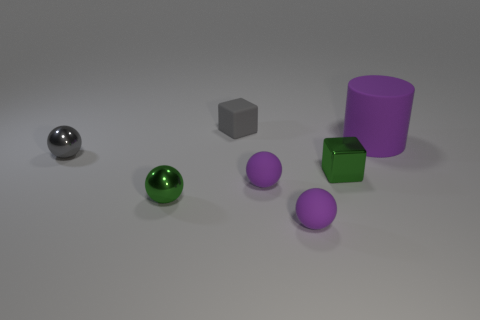Subtract 1 balls. How many balls are left? 3 Subtract all green blocks. Subtract all purple balls. How many blocks are left? 1 Add 2 purple cylinders. How many objects exist? 9 Subtract all blocks. How many objects are left? 5 Subtract all tiny purple metallic cylinders. Subtract all small gray balls. How many objects are left? 6 Add 3 green balls. How many green balls are left? 4 Add 5 tiny purple rubber balls. How many tiny purple rubber balls exist? 7 Subtract 0 gray cylinders. How many objects are left? 7 